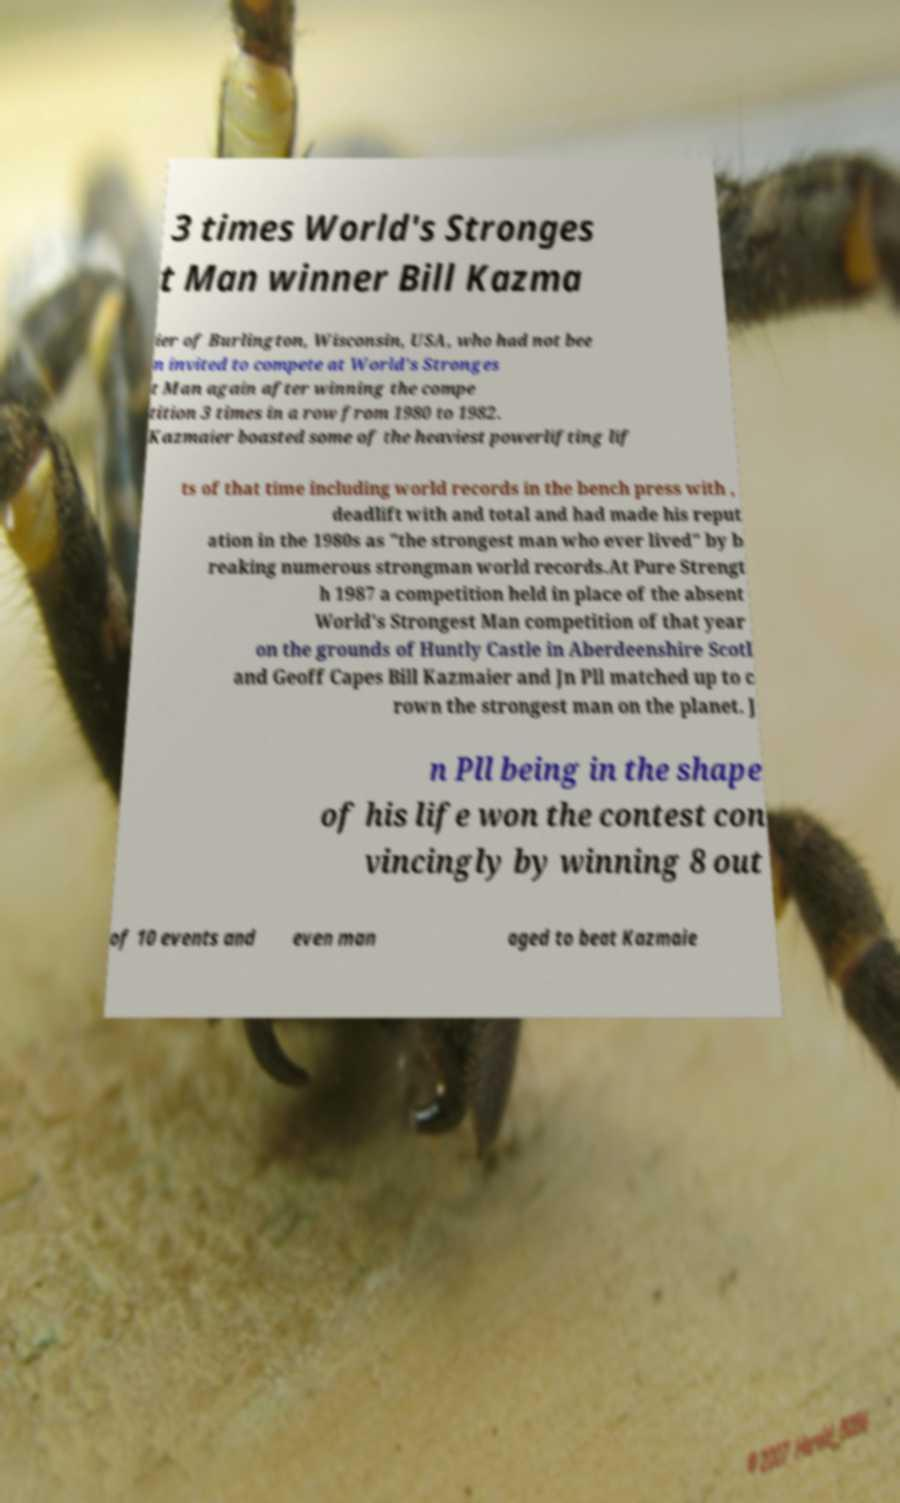Can you accurately transcribe the text from the provided image for me? 3 times World's Stronges t Man winner Bill Kazma ier of Burlington, Wisconsin, USA, who had not bee n invited to compete at World's Stronges t Man again after winning the compe tition 3 times in a row from 1980 to 1982. Kazmaier boasted some of the heaviest powerlifting lif ts of that time including world records in the bench press with , deadlift with and total and had made his reput ation in the 1980s as "the strongest man who ever lived" by b reaking numerous strongman world records.At Pure Strengt h 1987 a competition held in place of the absent World's Strongest Man competition of that year on the grounds of Huntly Castle in Aberdeenshire Scotl and Geoff Capes Bill Kazmaier and Jn Pll matched up to c rown the strongest man on the planet. J n Pll being in the shape of his life won the contest con vincingly by winning 8 out of 10 events and even man aged to beat Kazmaie 